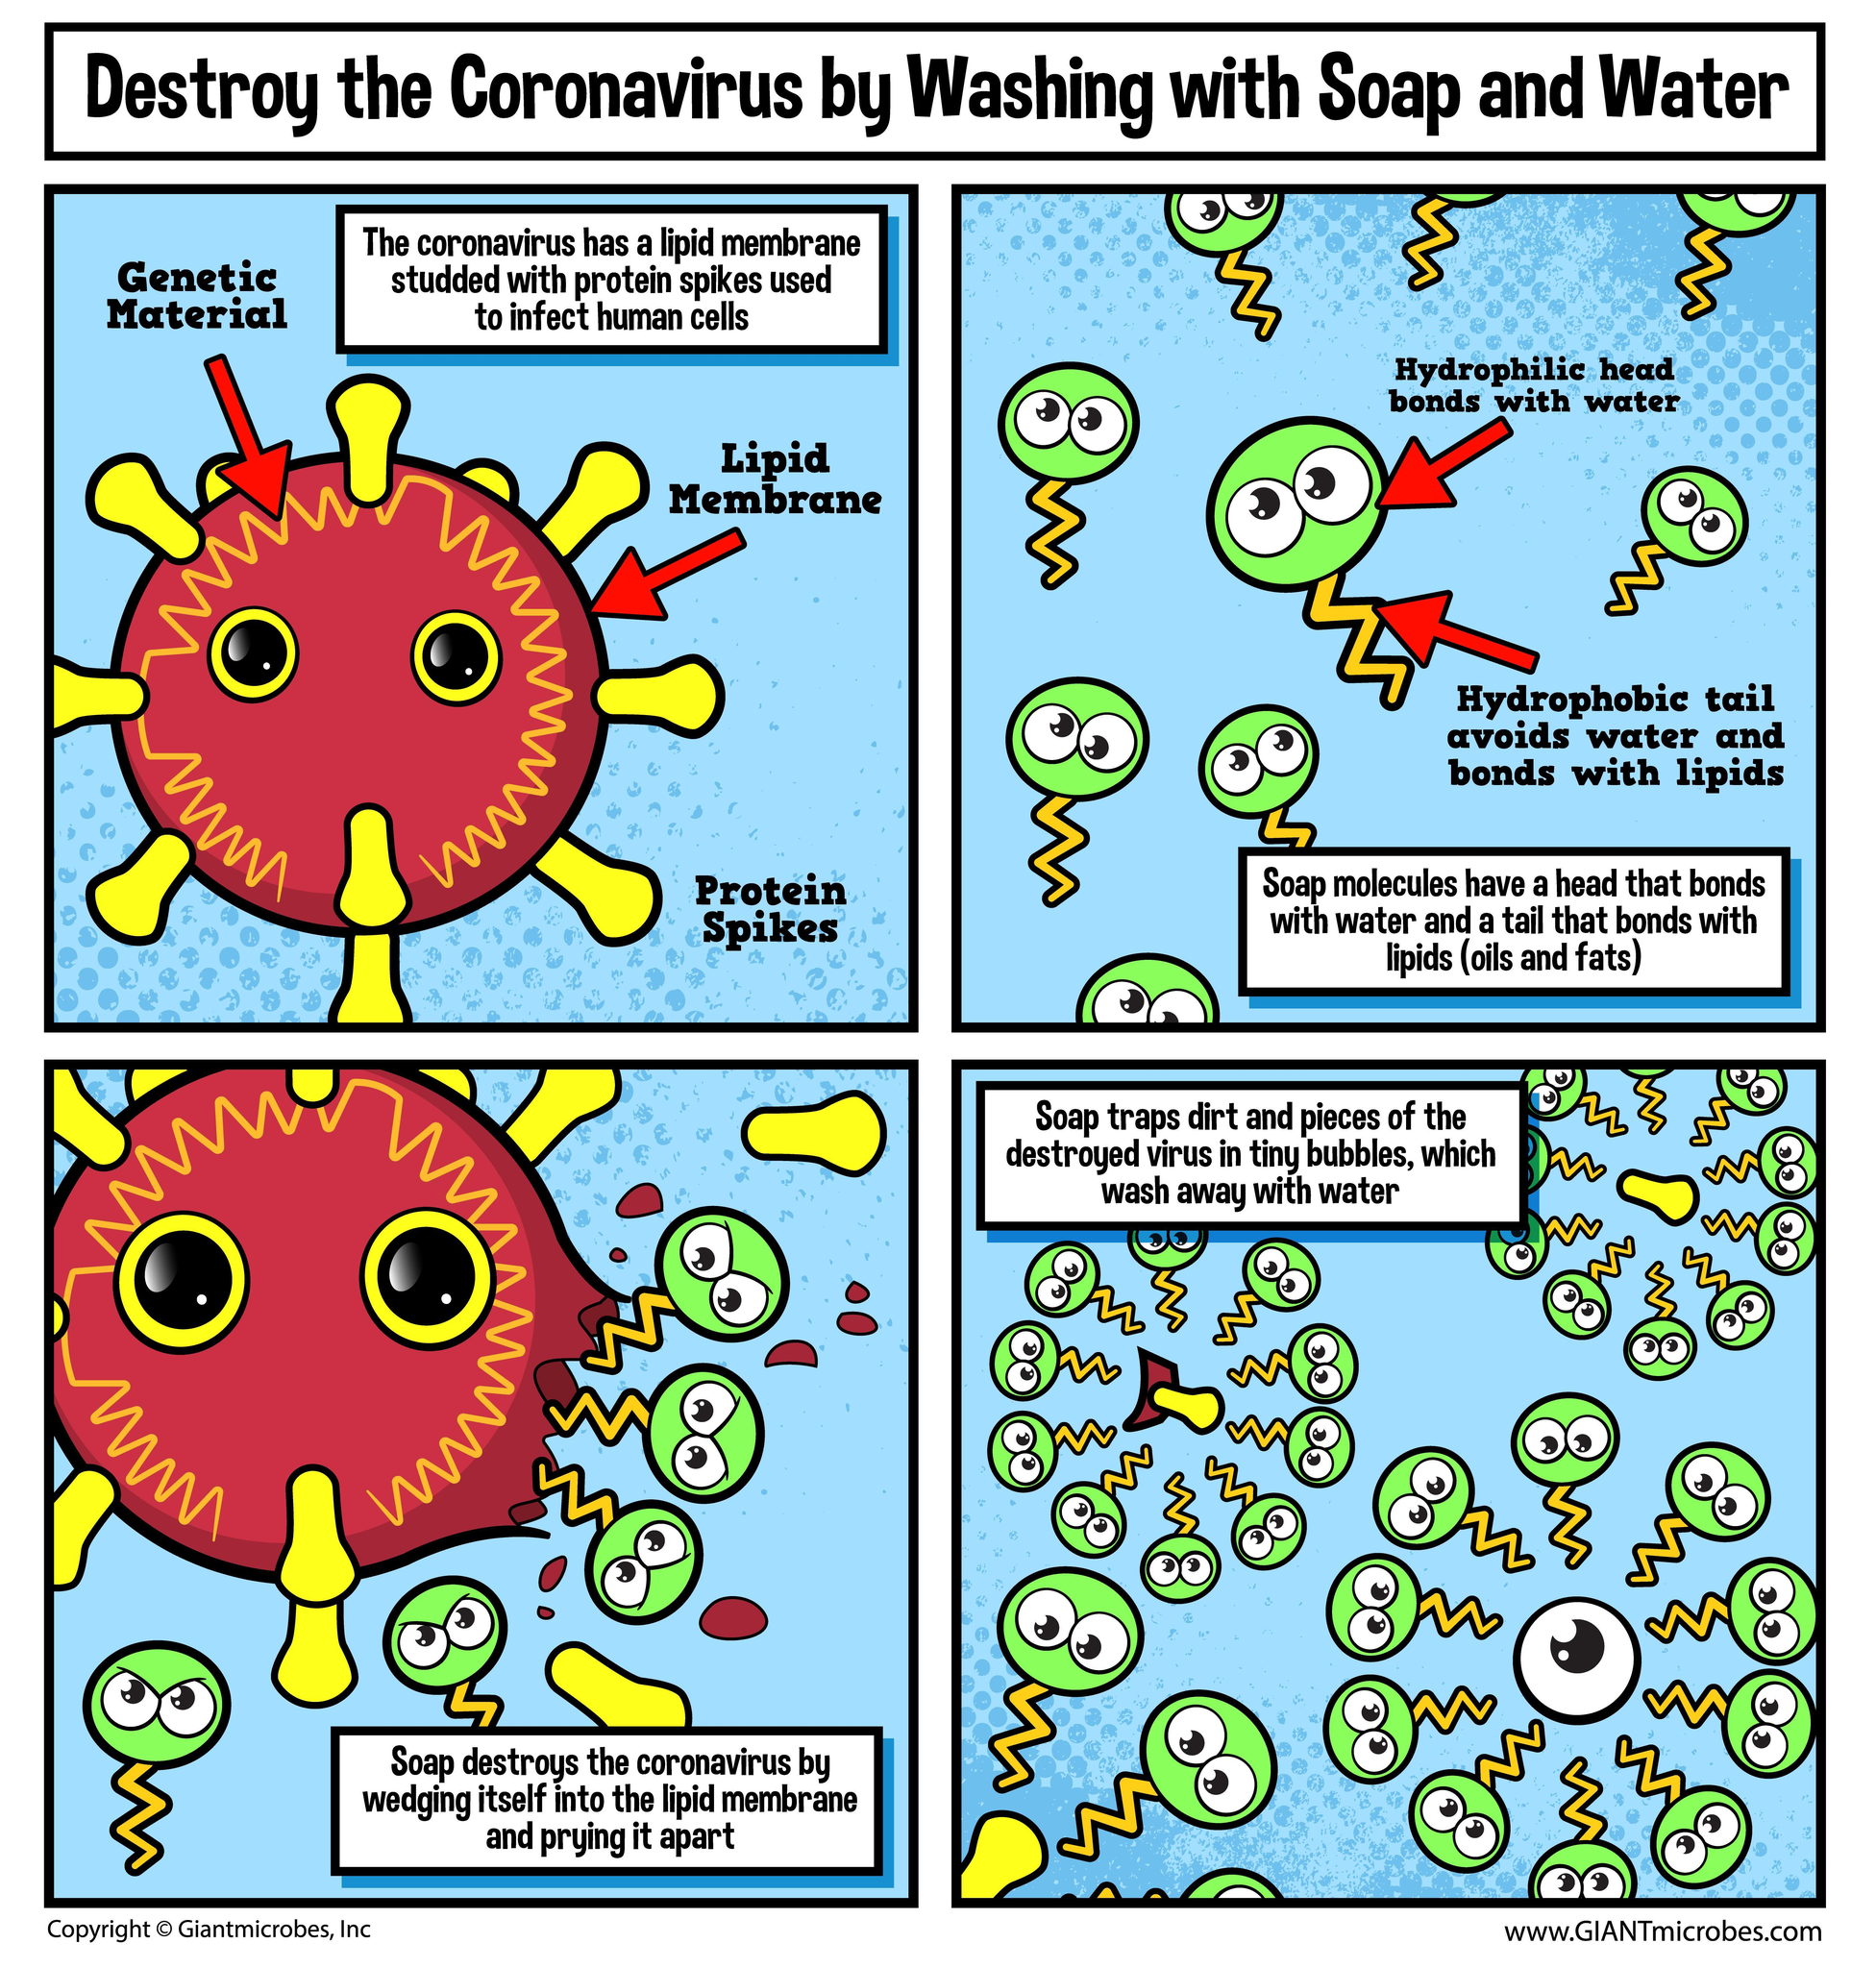What are the 3 parts of the coronavirus structure
Answer the question with a short phrase. genetic material, lipid membrane, protein spikes Which 2 parts does a soap molecule have hydrophilic head, hydrophobic tail What is the colour of the soap head, green or yellow green What is the colour of the protein spike, yellow or pink yellow 